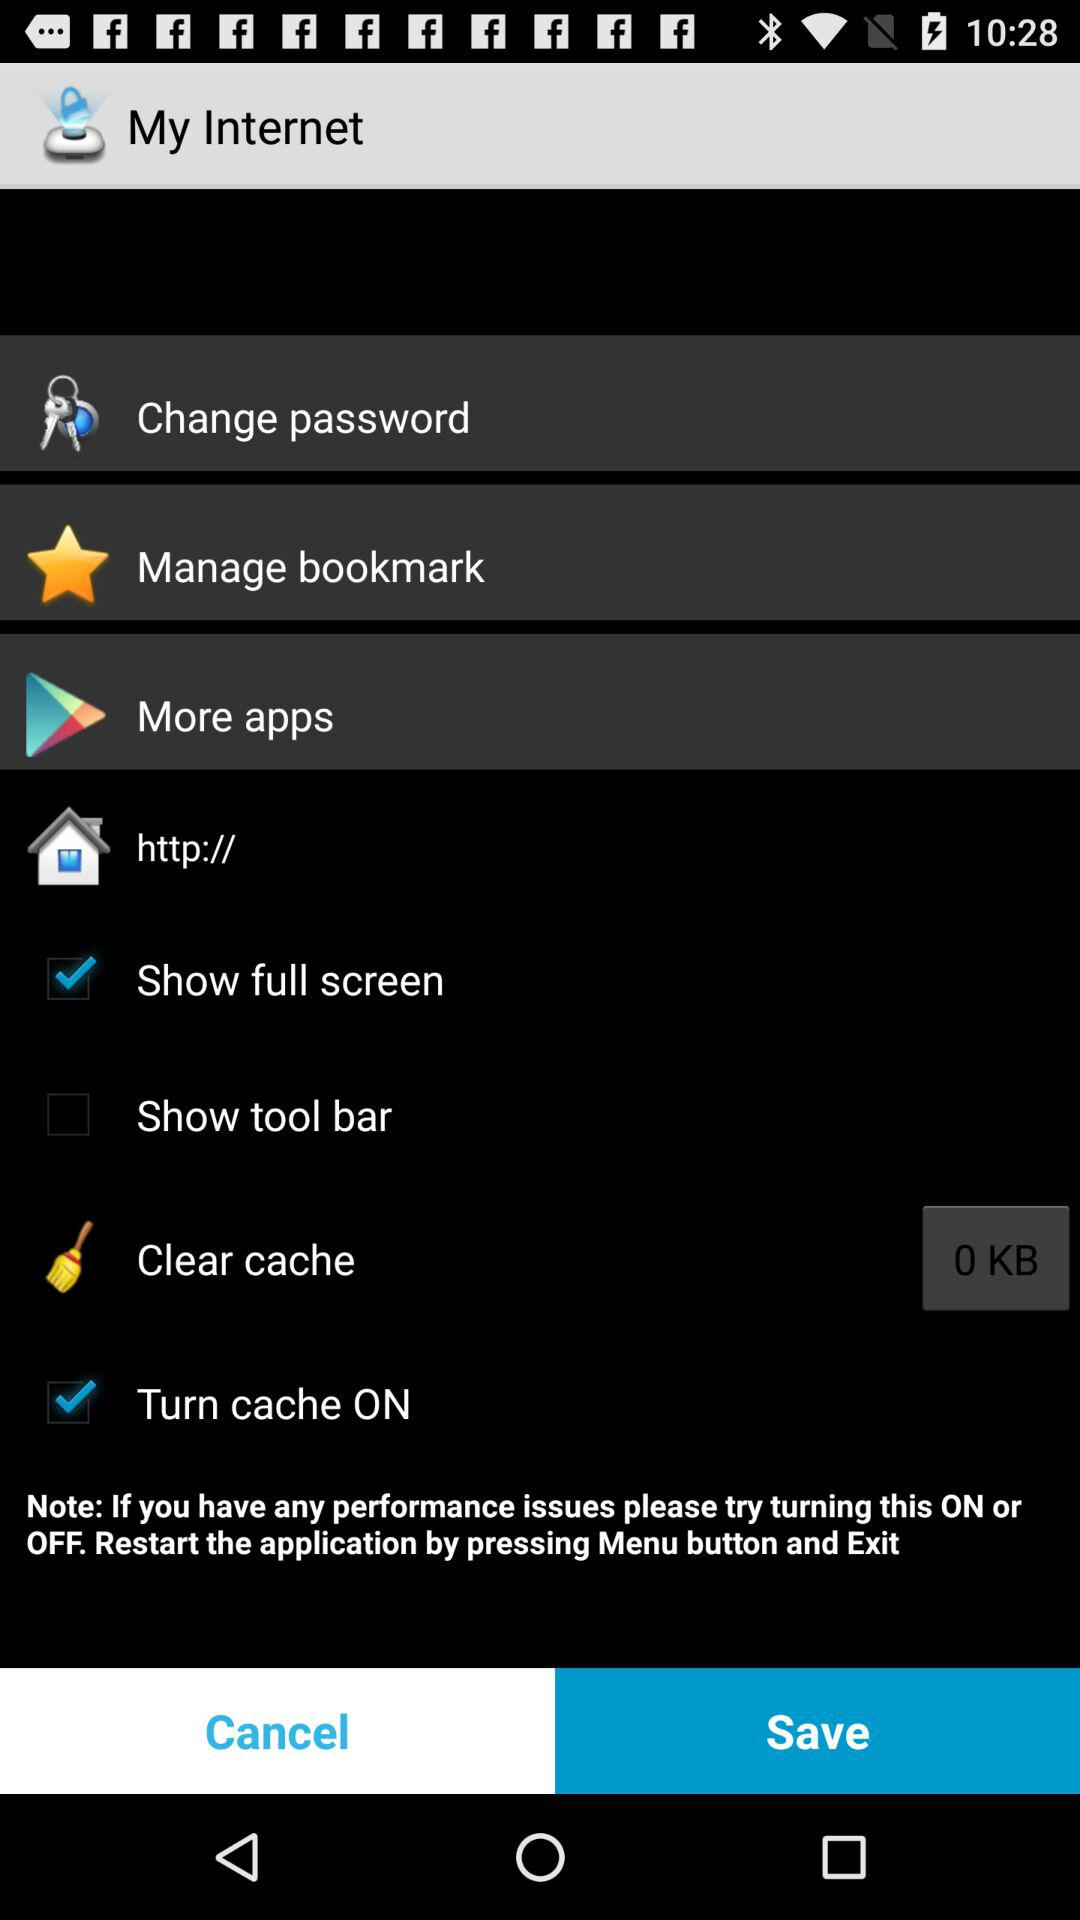What is the status of "Show full screen"? The status of "Show full screen" is "on". 